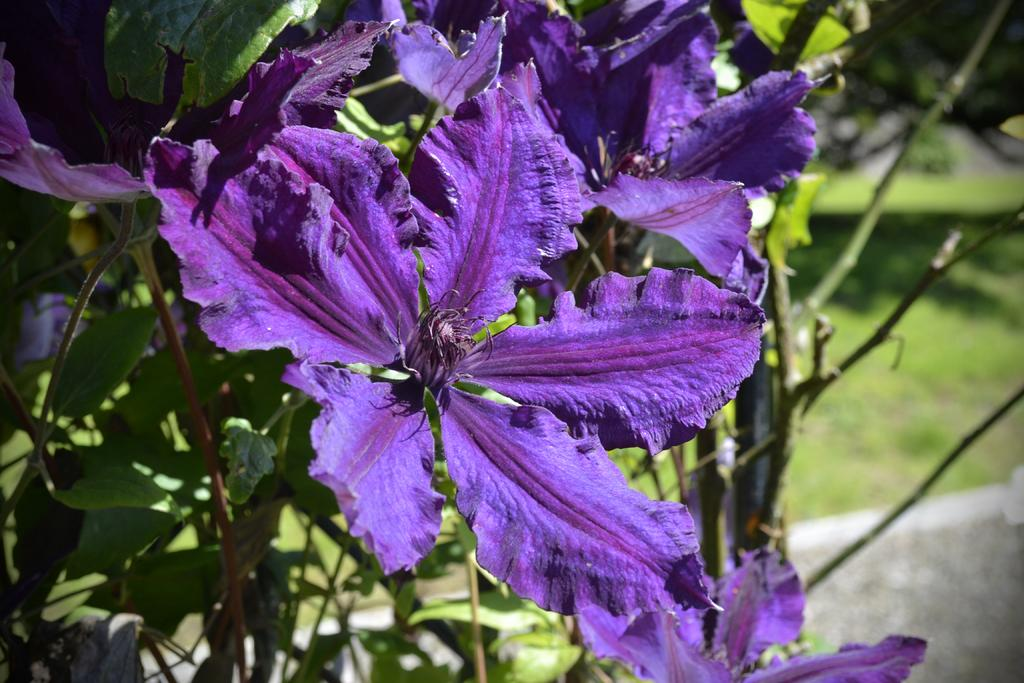What is present in the image? There is a plant in the image. What specific feature of the plant can be observed? The plant has flowers. What color are the flowers? The flowers are violet in color. What else can be seen in the background of the image? There are other plants visible in the background. What type of kite is being flown by the plant in the image? There is no kite present in the image; it features a plant with violet flowers and other plants in the background. 